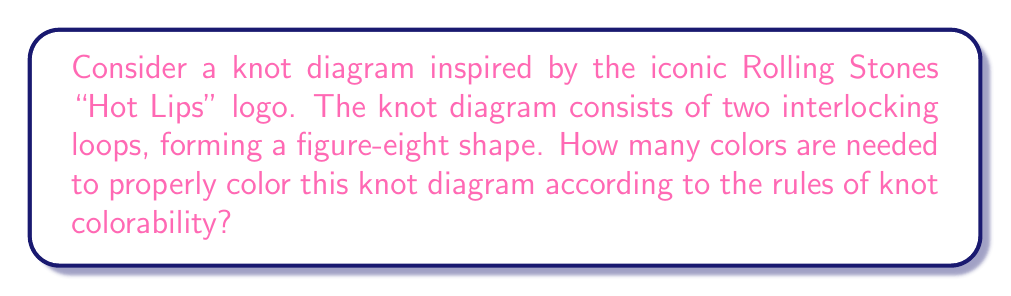Could you help me with this problem? Let's approach this step-by-step:

1. Recall the rules of knot colorability:
   - Each arc in the knot diagram must be assigned a color.
   - At each crossing, either all three arcs must have the same color, or all three must have different colors.

2. Let's visualize the knot diagram:
   [asy]
   import geometry;
   
   path p1 = (0,0)..(-1,1)..(0,2)..(1,1)..cycle;
   path p2 = (0,2)..(1,1)..(2,2)..(1,3)..cycle;
   
   draw(p1, linewidth(2));
   draw(p2, linewidth(2));
   
   dot((0,1), filltype=Fill(white));
   dot((1,2), filltype=Fill(white));
   [/asy]

3. This diagram has two crossings and four arcs.

4. Let's assign variables to the colors of each arc:
   - Let $a$ be the color of the top-left arc
   - Let $b$ be the color of the bottom-left arc
   - Let $c$ be the color of the top-right arc
   - Let $d$ be the color of the bottom-right arc

5. At the left crossing, we have arcs with colors $a$, $b$, and $d$.
   At the right crossing, we have arcs with colors $a$, $c$, and $d$.

6. For a proper coloring, we must have:
   $a \neq b \neq d$ and $a \neq c \neq d$

7. This means we need at least three colors to satisfy these conditions.

8. We can achieve a proper coloring with exactly three colors:
   - Assign color 1 to arcs $a$ and $c$
   - Assign color 2 to arc $b$
   - Assign color 3 to arc $d$

9. This coloring satisfies the rules at both crossings:
   - Left crossing: 1, 2, 3 (all different)
   - Right crossing: 1, 1, 3 (two same, one different)

10. Therefore, the minimum number of colors needed is 3.
Answer: 3 colors 